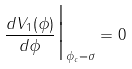<formula> <loc_0><loc_0><loc_500><loc_500>\frac { d V _ { 1 } ( \phi ) } { d \phi } \Big | _ { \phi _ { c } = \sigma } = 0</formula> 